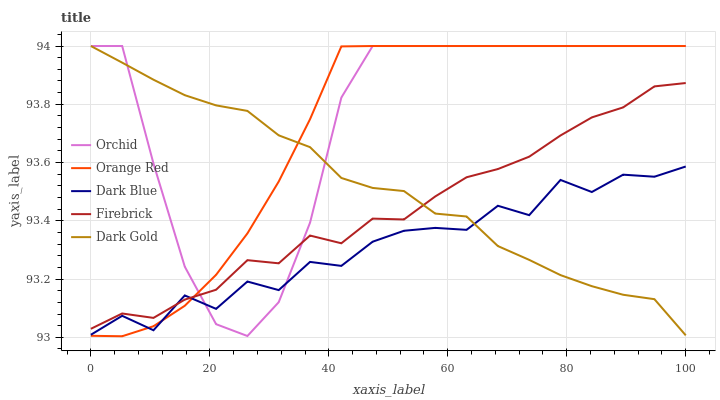Does Dark Blue have the minimum area under the curve?
Answer yes or no. Yes. Does Orchid have the maximum area under the curve?
Answer yes or no. Yes. Does Firebrick have the minimum area under the curve?
Answer yes or no. No. Does Firebrick have the maximum area under the curve?
Answer yes or no. No. Is Orange Red the smoothest?
Answer yes or no. Yes. Is Dark Blue the roughest?
Answer yes or no. Yes. Is Firebrick the smoothest?
Answer yes or no. No. Is Firebrick the roughest?
Answer yes or no. No. Does Orange Red have the lowest value?
Answer yes or no. Yes. Does Dark Gold have the lowest value?
Answer yes or no. No. Does Orchid have the highest value?
Answer yes or no. Yes. Does Firebrick have the highest value?
Answer yes or no. No. Does Orchid intersect Dark Blue?
Answer yes or no. Yes. Is Orchid less than Dark Blue?
Answer yes or no. No. Is Orchid greater than Dark Blue?
Answer yes or no. No. 